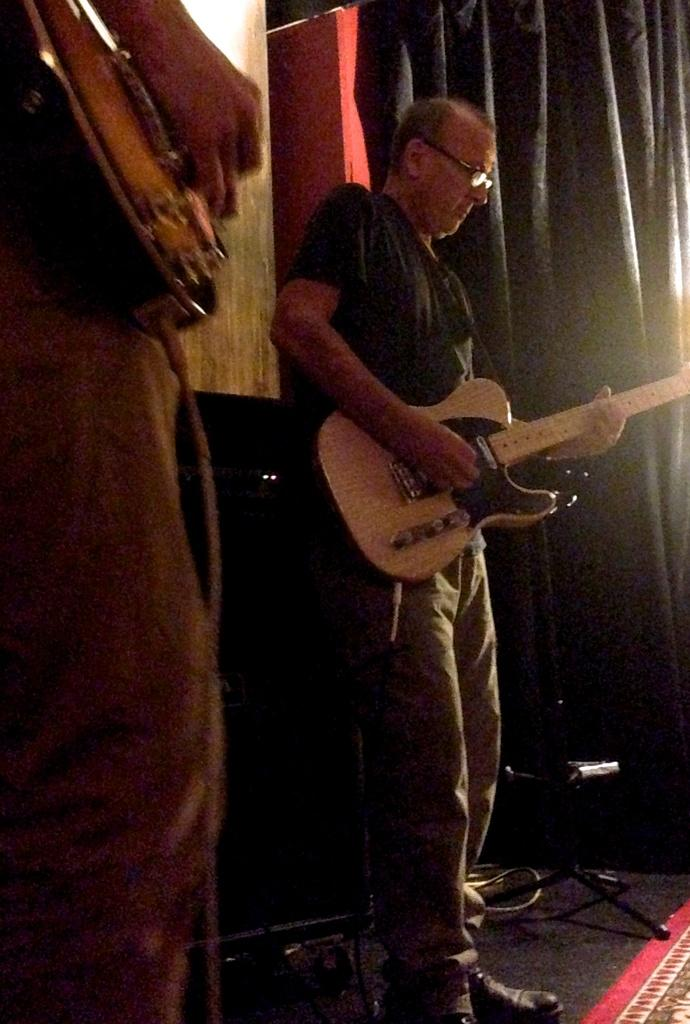How many people are in the image? There are two persons in the image. What are the persons holding in the image? The persons are holding guitars. What type of watch is the person wearing in the image? There is no watch visible in the image, as the persons are holding guitars. 